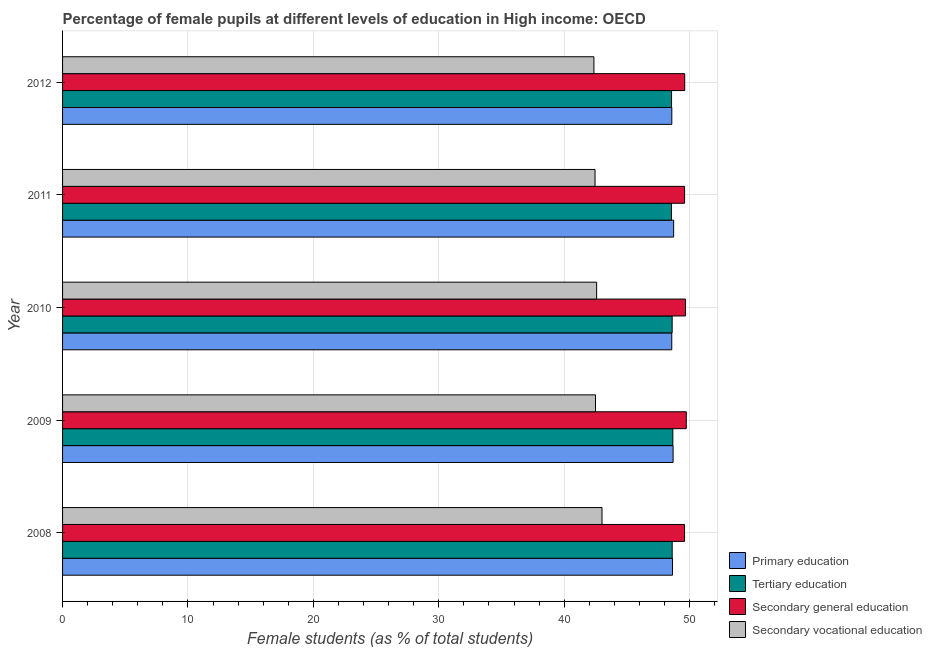How many groups of bars are there?
Your answer should be compact. 5. Are the number of bars per tick equal to the number of legend labels?
Provide a succinct answer. Yes. Are the number of bars on each tick of the Y-axis equal?
Ensure brevity in your answer.  Yes. How many bars are there on the 5th tick from the top?
Offer a very short reply. 4. How many bars are there on the 1st tick from the bottom?
Offer a terse response. 4. In how many cases, is the number of bars for a given year not equal to the number of legend labels?
Make the answer very short. 0. What is the percentage of female students in secondary vocational education in 2011?
Provide a succinct answer. 42.46. Across all years, what is the maximum percentage of female students in secondary vocational education?
Your answer should be compact. 43.01. Across all years, what is the minimum percentage of female students in secondary education?
Provide a short and direct response. 49.59. What is the total percentage of female students in primary education in the graph?
Your answer should be compact. 243.19. What is the difference between the percentage of female students in secondary education in 2008 and that in 2010?
Provide a short and direct response. -0.07. What is the difference between the percentage of female students in secondary vocational education in 2009 and the percentage of female students in tertiary education in 2012?
Ensure brevity in your answer.  -6.07. What is the average percentage of female students in tertiary education per year?
Your answer should be compact. 48.6. In the year 2010, what is the difference between the percentage of female students in secondary education and percentage of female students in secondary vocational education?
Offer a very short reply. 7.08. In how many years, is the percentage of female students in primary education greater than 48 %?
Your response must be concise. 5. Is the percentage of female students in secondary education in 2011 less than that in 2012?
Offer a very short reply. Yes. What is the difference between the highest and the second highest percentage of female students in secondary education?
Keep it short and to the point. 0.07. What is the difference between the highest and the lowest percentage of female students in primary education?
Your response must be concise. 0.15. In how many years, is the percentage of female students in primary education greater than the average percentage of female students in primary education taken over all years?
Offer a terse response. 2. Is the sum of the percentage of female students in tertiary education in 2008 and 2012 greater than the maximum percentage of female students in secondary education across all years?
Your response must be concise. Yes. What does the 2nd bar from the top in 2008 represents?
Ensure brevity in your answer.  Secondary general education. What does the 3rd bar from the bottom in 2008 represents?
Provide a succinct answer. Secondary general education. What is the difference between two consecutive major ticks on the X-axis?
Make the answer very short. 10. What is the title of the graph?
Provide a succinct answer. Percentage of female pupils at different levels of education in High income: OECD. What is the label or title of the X-axis?
Your answer should be very brief. Female students (as % of total students). What is the label or title of the Y-axis?
Offer a terse response. Year. What is the Female students (as % of total students) in Primary education in 2008?
Offer a terse response. 48.63. What is the Female students (as % of total students) in Tertiary education in 2008?
Provide a succinct answer. 48.61. What is the Female students (as % of total students) of Secondary general education in 2008?
Provide a succinct answer. 49.59. What is the Female students (as % of total students) in Secondary vocational education in 2008?
Offer a very short reply. 43.01. What is the Female students (as % of total students) in Primary education in 2009?
Offer a terse response. 48.68. What is the Female students (as % of total students) of Tertiary education in 2009?
Make the answer very short. 48.66. What is the Female students (as % of total students) of Secondary general education in 2009?
Offer a terse response. 49.73. What is the Female students (as % of total students) of Secondary vocational education in 2009?
Ensure brevity in your answer.  42.49. What is the Female students (as % of total students) in Primary education in 2010?
Your answer should be very brief. 48.57. What is the Female students (as % of total students) of Tertiary education in 2010?
Your response must be concise. 48.61. What is the Female students (as % of total students) of Secondary general education in 2010?
Make the answer very short. 49.67. What is the Female students (as % of total students) in Secondary vocational education in 2010?
Ensure brevity in your answer.  42.59. What is the Female students (as % of total students) of Primary education in 2011?
Offer a very short reply. 48.73. What is the Female students (as % of total students) in Tertiary education in 2011?
Offer a terse response. 48.55. What is the Female students (as % of total students) in Secondary general education in 2011?
Offer a very short reply. 49.6. What is the Female students (as % of total students) of Secondary vocational education in 2011?
Keep it short and to the point. 42.46. What is the Female students (as % of total students) of Primary education in 2012?
Keep it short and to the point. 48.58. What is the Female students (as % of total students) of Tertiary education in 2012?
Your answer should be compact. 48.56. What is the Female students (as % of total students) in Secondary general education in 2012?
Provide a succinct answer. 49.61. What is the Female students (as % of total students) in Secondary vocational education in 2012?
Your answer should be compact. 42.37. Across all years, what is the maximum Female students (as % of total students) of Primary education?
Give a very brief answer. 48.73. Across all years, what is the maximum Female students (as % of total students) in Tertiary education?
Your response must be concise. 48.66. Across all years, what is the maximum Female students (as % of total students) of Secondary general education?
Your answer should be very brief. 49.73. Across all years, what is the maximum Female students (as % of total students) of Secondary vocational education?
Provide a succinct answer. 43.01. Across all years, what is the minimum Female students (as % of total students) of Primary education?
Offer a terse response. 48.57. Across all years, what is the minimum Female students (as % of total students) in Tertiary education?
Your answer should be very brief. 48.55. Across all years, what is the minimum Female students (as % of total students) of Secondary general education?
Give a very brief answer. 49.59. Across all years, what is the minimum Female students (as % of total students) of Secondary vocational education?
Offer a very short reply. 42.37. What is the total Female students (as % of total students) in Primary education in the graph?
Make the answer very short. 243.19. What is the total Female students (as % of total students) in Tertiary education in the graph?
Ensure brevity in your answer.  242.98. What is the total Female students (as % of total students) of Secondary general education in the graph?
Keep it short and to the point. 248.2. What is the total Female students (as % of total students) of Secondary vocational education in the graph?
Ensure brevity in your answer.  212.92. What is the difference between the Female students (as % of total students) of Primary education in 2008 and that in 2009?
Your answer should be very brief. -0.05. What is the difference between the Female students (as % of total students) of Tertiary education in 2008 and that in 2009?
Provide a short and direct response. -0.05. What is the difference between the Female students (as % of total students) of Secondary general education in 2008 and that in 2009?
Your response must be concise. -0.14. What is the difference between the Female students (as % of total students) of Secondary vocational education in 2008 and that in 2009?
Keep it short and to the point. 0.52. What is the difference between the Female students (as % of total students) of Primary education in 2008 and that in 2010?
Provide a succinct answer. 0.06. What is the difference between the Female students (as % of total students) in Tertiary education in 2008 and that in 2010?
Offer a terse response. 0. What is the difference between the Female students (as % of total students) of Secondary general education in 2008 and that in 2010?
Make the answer very short. -0.07. What is the difference between the Female students (as % of total students) of Secondary vocational education in 2008 and that in 2010?
Give a very brief answer. 0.43. What is the difference between the Female students (as % of total students) in Primary education in 2008 and that in 2011?
Offer a very short reply. -0.09. What is the difference between the Female students (as % of total students) of Tertiary education in 2008 and that in 2011?
Keep it short and to the point. 0.06. What is the difference between the Female students (as % of total students) of Secondary general education in 2008 and that in 2011?
Give a very brief answer. -0. What is the difference between the Female students (as % of total students) in Secondary vocational education in 2008 and that in 2011?
Your answer should be very brief. 0.56. What is the difference between the Female students (as % of total students) in Primary education in 2008 and that in 2012?
Keep it short and to the point. 0.06. What is the difference between the Female students (as % of total students) in Tertiary education in 2008 and that in 2012?
Offer a terse response. 0.05. What is the difference between the Female students (as % of total students) of Secondary general education in 2008 and that in 2012?
Provide a short and direct response. -0.01. What is the difference between the Female students (as % of total students) of Secondary vocational education in 2008 and that in 2012?
Make the answer very short. 0.64. What is the difference between the Female students (as % of total students) in Primary education in 2009 and that in 2010?
Provide a short and direct response. 0.11. What is the difference between the Female students (as % of total students) in Tertiary education in 2009 and that in 2010?
Provide a short and direct response. 0.06. What is the difference between the Female students (as % of total students) in Secondary general education in 2009 and that in 2010?
Your response must be concise. 0.07. What is the difference between the Female students (as % of total students) of Secondary vocational education in 2009 and that in 2010?
Offer a terse response. -0.09. What is the difference between the Female students (as % of total students) of Primary education in 2009 and that in 2011?
Your response must be concise. -0.05. What is the difference between the Female students (as % of total students) in Tertiary education in 2009 and that in 2011?
Provide a short and direct response. 0.11. What is the difference between the Female students (as % of total students) of Secondary general education in 2009 and that in 2011?
Offer a terse response. 0.14. What is the difference between the Female students (as % of total students) in Secondary vocational education in 2009 and that in 2011?
Your answer should be very brief. 0.04. What is the difference between the Female students (as % of total students) in Primary education in 2009 and that in 2012?
Give a very brief answer. 0.1. What is the difference between the Female students (as % of total students) of Tertiary education in 2009 and that in 2012?
Offer a terse response. 0.1. What is the difference between the Female students (as % of total students) of Secondary general education in 2009 and that in 2012?
Offer a very short reply. 0.13. What is the difference between the Female students (as % of total students) in Secondary vocational education in 2009 and that in 2012?
Offer a terse response. 0.12. What is the difference between the Female students (as % of total students) of Primary education in 2010 and that in 2011?
Ensure brevity in your answer.  -0.15. What is the difference between the Female students (as % of total students) of Tertiary education in 2010 and that in 2011?
Your response must be concise. 0.06. What is the difference between the Female students (as % of total students) in Secondary general education in 2010 and that in 2011?
Your answer should be very brief. 0.07. What is the difference between the Female students (as % of total students) of Secondary vocational education in 2010 and that in 2011?
Your answer should be compact. 0.13. What is the difference between the Female students (as % of total students) in Primary education in 2010 and that in 2012?
Keep it short and to the point. -0. What is the difference between the Female students (as % of total students) in Tertiary education in 2010 and that in 2012?
Make the answer very short. 0.05. What is the difference between the Female students (as % of total students) in Secondary vocational education in 2010 and that in 2012?
Ensure brevity in your answer.  0.22. What is the difference between the Female students (as % of total students) of Primary education in 2011 and that in 2012?
Provide a short and direct response. 0.15. What is the difference between the Female students (as % of total students) of Tertiary education in 2011 and that in 2012?
Your answer should be compact. -0.01. What is the difference between the Female students (as % of total students) in Secondary general education in 2011 and that in 2012?
Your answer should be very brief. -0.01. What is the difference between the Female students (as % of total students) in Secondary vocational education in 2011 and that in 2012?
Ensure brevity in your answer.  0.09. What is the difference between the Female students (as % of total students) of Primary education in 2008 and the Female students (as % of total students) of Tertiary education in 2009?
Give a very brief answer. -0.03. What is the difference between the Female students (as % of total students) of Primary education in 2008 and the Female students (as % of total students) of Secondary general education in 2009?
Make the answer very short. -1.1. What is the difference between the Female students (as % of total students) in Primary education in 2008 and the Female students (as % of total students) in Secondary vocational education in 2009?
Offer a terse response. 6.14. What is the difference between the Female students (as % of total students) of Tertiary education in 2008 and the Female students (as % of total students) of Secondary general education in 2009?
Offer a very short reply. -1.12. What is the difference between the Female students (as % of total students) of Tertiary education in 2008 and the Female students (as % of total students) of Secondary vocational education in 2009?
Provide a succinct answer. 6.12. What is the difference between the Female students (as % of total students) of Secondary general education in 2008 and the Female students (as % of total students) of Secondary vocational education in 2009?
Provide a succinct answer. 7.1. What is the difference between the Female students (as % of total students) in Primary education in 2008 and the Female students (as % of total students) in Tertiary education in 2010?
Keep it short and to the point. 0.03. What is the difference between the Female students (as % of total students) in Primary education in 2008 and the Female students (as % of total students) in Secondary general education in 2010?
Make the answer very short. -1.03. What is the difference between the Female students (as % of total students) in Primary education in 2008 and the Female students (as % of total students) in Secondary vocational education in 2010?
Keep it short and to the point. 6.05. What is the difference between the Female students (as % of total students) of Tertiary education in 2008 and the Female students (as % of total students) of Secondary general education in 2010?
Your answer should be very brief. -1.06. What is the difference between the Female students (as % of total students) of Tertiary education in 2008 and the Female students (as % of total students) of Secondary vocational education in 2010?
Offer a terse response. 6.02. What is the difference between the Female students (as % of total students) of Secondary general education in 2008 and the Female students (as % of total students) of Secondary vocational education in 2010?
Ensure brevity in your answer.  7.01. What is the difference between the Female students (as % of total students) in Primary education in 2008 and the Female students (as % of total students) in Tertiary education in 2011?
Your answer should be compact. 0.09. What is the difference between the Female students (as % of total students) in Primary education in 2008 and the Female students (as % of total students) in Secondary general education in 2011?
Provide a short and direct response. -0.96. What is the difference between the Female students (as % of total students) of Primary education in 2008 and the Female students (as % of total students) of Secondary vocational education in 2011?
Your answer should be compact. 6.18. What is the difference between the Female students (as % of total students) in Tertiary education in 2008 and the Female students (as % of total students) in Secondary general education in 2011?
Provide a short and direct response. -0.99. What is the difference between the Female students (as % of total students) of Tertiary education in 2008 and the Female students (as % of total students) of Secondary vocational education in 2011?
Offer a terse response. 6.15. What is the difference between the Female students (as % of total students) in Secondary general education in 2008 and the Female students (as % of total students) in Secondary vocational education in 2011?
Offer a very short reply. 7.14. What is the difference between the Female students (as % of total students) in Primary education in 2008 and the Female students (as % of total students) in Tertiary education in 2012?
Provide a short and direct response. 0.08. What is the difference between the Female students (as % of total students) in Primary education in 2008 and the Female students (as % of total students) in Secondary general education in 2012?
Your answer should be compact. -0.97. What is the difference between the Female students (as % of total students) of Primary education in 2008 and the Female students (as % of total students) of Secondary vocational education in 2012?
Give a very brief answer. 6.27. What is the difference between the Female students (as % of total students) of Tertiary education in 2008 and the Female students (as % of total students) of Secondary general education in 2012?
Offer a very short reply. -1. What is the difference between the Female students (as % of total students) of Tertiary education in 2008 and the Female students (as % of total students) of Secondary vocational education in 2012?
Give a very brief answer. 6.24. What is the difference between the Female students (as % of total students) in Secondary general education in 2008 and the Female students (as % of total students) in Secondary vocational education in 2012?
Give a very brief answer. 7.23. What is the difference between the Female students (as % of total students) in Primary education in 2009 and the Female students (as % of total students) in Tertiary education in 2010?
Provide a short and direct response. 0.07. What is the difference between the Female students (as % of total students) in Primary education in 2009 and the Female students (as % of total students) in Secondary general education in 2010?
Give a very brief answer. -0.99. What is the difference between the Female students (as % of total students) of Primary education in 2009 and the Female students (as % of total students) of Secondary vocational education in 2010?
Your response must be concise. 6.1. What is the difference between the Female students (as % of total students) in Tertiary education in 2009 and the Female students (as % of total students) in Secondary general education in 2010?
Offer a terse response. -1.01. What is the difference between the Female students (as % of total students) of Tertiary education in 2009 and the Female students (as % of total students) of Secondary vocational education in 2010?
Provide a succinct answer. 6.08. What is the difference between the Female students (as % of total students) of Secondary general education in 2009 and the Female students (as % of total students) of Secondary vocational education in 2010?
Keep it short and to the point. 7.15. What is the difference between the Female students (as % of total students) in Primary education in 2009 and the Female students (as % of total students) in Tertiary education in 2011?
Give a very brief answer. 0.13. What is the difference between the Female students (as % of total students) of Primary education in 2009 and the Female students (as % of total students) of Secondary general education in 2011?
Your answer should be compact. -0.92. What is the difference between the Female students (as % of total students) in Primary education in 2009 and the Female students (as % of total students) in Secondary vocational education in 2011?
Make the answer very short. 6.22. What is the difference between the Female students (as % of total students) in Tertiary education in 2009 and the Female students (as % of total students) in Secondary general education in 2011?
Keep it short and to the point. -0.94. What is the difference between the Female students (as % of total students) of Tertiary education in 2009 and the Female students (as % of total students) of Secondary vocational education in 2011?
Your response must be concise. 6.2. What is the difference between the Female students (as % of total students) of Secondary general education in 2009 and the Female students (as % of total students) of Secondary vocational education in 2011?
Provide a succinct answer. 7.28. What is the difference between the Female students (as % of total students) in Primary education in 2009 and the Female students (as % of total students) in Tertiary education in 2012?
Ensure brevity in your answer.  0.12. What is the difference between the Female students (as % of total students) of Primary education in 2009 and the Female students (as % of total students) of Secondary general education in 2012?
Offer a terse response. -0.93. What is the difference between the Female students (as % of total students) of Primary education in 2009 and the Female students (as % of total students) of Secondary vocational education in 2012?
Your answer should be compact. 6.31. What is the difference between the Female students (as % of total students) in Tertiary education in 2009 and the Female students (as % of total students) in Secondary general education in 2012?
Offer a terse response. -0.95. What is the difference between the Female students (as % of total students) in Tertiary education in 2009 and the Female students (as % of total students) in Secondary vocational education in 2012?
Provide a succinct answer. 6.29. What is the difference between the Female students (as % of total students) of Secondary general education in 2009 and the Female students (as % of total students) of Secondary vocational education in 2012?
Make the answer very short. 7.36. What is the difference between the Female students (as % of total students) of Primary education in 2010 and the Female students (as % of total students) of Tertiary education in 2011?
Your answer should be very brief. 0.03. What is the difference between the Female students (as % of total students) of Primary education in 2010 and the Female students (as % of total students) of Secondary general education in 2011?
Make the answer very short. -1.02. What is the difference between the Female students (as % of total students) of Primary education in 2010 and the Female students (as % of total students) of Secondary vocational education in 2011?
Provide a succinct answer. 6.12. What is the difference between the Female students (as % of total students) of Tertiary education in 2010 and the Female students (as % of total students) of Secondary general education in 2011?
Provide a short and direct response. -0.99. What is the difference between the Female students (as % of total students) of Tertiary education in 2010 and the Female students (as % of total students) of Secondary vocational education in 2011?
Ensure brevity in your answer.  6.15. What is the difference between the Female students (as % of total students) in Secondary general education in 2010 and the Female students (as % of total students) in Secondary vocational education in 2011?
Provide a succinct answer. 7.21. What is the difference between the Female students (as % of total students) in Primary education in 2010 and the Female students (as % of total students) in Tertiary education in 2012?
Your answer should be very brief. 0.02. What is the difference between the Female students (as % of total students) of Primary education in 2010 and the Female students (as % of total students) of Secondary general education in 2012?
Provide a succinct answer. -1.03. What is the difference between the Female students (as % of total students) of Primary education in 2010 and the Female students (as % of total students) of Secondary vocational education in 2012?
Offer a very short reply. 6.21. What is the difference between the Female students (as % of total students) in Tertiary education in 2010 and the Female students (as % of total students) in Secondary general education in 2012?
Give a very brief answer. -1. What is the difference between the Female students (as % of total students) in Tertiary education in 2010 and the Female students (as % of total students) in Secondary vocational education in 2012?
Keep it short and to the point. 6.24. What is the difference between the Female students (as % of total students) in Secondary general education in 2010 and the Female students (as % of total students) in Secondary vocational education in 2012?
Provide a short and direct response. 7.3. What is the difference between the Female students (as % of total students) in Primary education in 2011 and the Female students (as % of total students) in Tertiary education in 2012?
Ensure brevity in your answer.  0.17. What is the difference between the Female students (as % of total students) of Primary education in 2011 and the Female students (as % of total students) of Secondary general education in 2012?
Offer a terse response. -0.88. What is the difference between the Female students (as % of total students) in Primary education in 2011 and the Female students (as % of total students) in Secondary vocational education in 2012?
Your answer should be compact. 6.36. What is the difference between the Female students (as % of total students) in Tertiary education in 2011 and the Female students (as % of total students) in Secondary general education in 2012?
Offer a terse response. -1.06. What is the difference between the Female students (as % of total students) in Tertiary education in 2011 and the Female students (as % of total students) in Secondary vocational education in 2012?
Give a very brief answer. 6.18. What is the difference between the Female students (as % of total students) of Secondary general education in 2011 and the Female students (as % of total students) of Secondary vocational education in 2012?
Your response must be concise. 7.23. What is the average Female students (as % of total students) of Primary education per year?
Provide a short and direct response. 48.64. What is the average Female students (as % of total students) in Tertiary education per year?
Provide a short and direct response. 48.6. What is the average Female students (as % of total students) of Secondary general education per year?
Give a very brief answer. 49.64. What is the average Female students (as % of total students) in Secondary vocational education per year?
Ensure brevity in your answer.  42.58. In the year 2008, what is the difference between the Female students (as % of total students) of Primary education and Female students (as % of total students) of Tertiary education?
Your response must be concise. 0.03. In the year 2008, what is the difference between the Female students (as % of total students) in Primary education and Female students (as % of total students) in Secondary general education?
Your answer should be compact. -0.96. In the year 2008, what is the difference between the Female students (as % of total students) in Primary education and Female students (as % of total students) in Secondary vocational education?
Offer a terse response. 5.62. In the year 2008, what is the difference between the Female students (as % of total students) in Tertiary education and Female students (as % of total students) in Secondary general education?
Keep it short and to the point. -0.99. In the year 2008, what is the difference between the Female students (as % of total students) of Tertiary education and Female students (as % of total students) of Secondary vocational education?
Ensure brevity in your answer.  5.6. In the year 2008, what is the difference between the Female students (as % of total students) in Secondary general education and Female students (as % of total students) in Secondary vocational education?
Offer a terse response. 6.58. In the year 2009, what is the difference between the Female students (as % of total students) in Primary education and Female students (as % of total students) in Tertiary education?
Offer a very short reply. 0.02. In the year 2009, what is the difference between the Female students (as % of total students) of Primary education and Female students (as % of total students) of Secondary general education?
Offer a terse response. -1.05. In the year 2009, what is the difference between the Female students (as % of total students) of Primary education and Female students (as % of total students) of Secondary vocational education?
Your response must be concise. 6.19. In the year 2009, what is the difference between the Female students (as % of total students) of Tertiary education and Female students (as % of total students) of Secondary general education?
Make the answer very short. -1.07. In the year 2009, what is the difference between the Female students (as % of total students) in Tertiary education and Female students (as % of total students) in Secondary vocational education?
Provide a succinct answer. 6.17. In the year 2009, what is the difference between the Female students (as % of total students) in Secondary general education and Female students (as % of total students) in Secondary vocational education?
Your response must be concise. 7.24. In the year 2010, what is the difference between the Female students (as % of total students) in Primary education and Female students (as % of total students) in Tertiary education?
Your answer should be compact. -0.03. In the year 2010, what is the difference between the Female students (as % of total students) in Primary education and Female students (as % of total students) in Secondary general education?
Provide a short and direct response. -1.09. In the year 2010, what is the difference between the Female students (as % of total students) in Primary education and Female students (as % of total students) in Secondary vocational education?
Offer a terse response. 5.99. In the year 2010, what is the difference between the Female students (as % of total students) of Tertiary education and Female students (as % of total students) of Secondary general education?
Your answer should be very brief. -1.06. In the year 2010, what is the difference between the Female students (as % of total students) of Tertiary education and Female students (as % of total students) of Secondary vocational education?
Ensure brevity in your answer.  6.02. In the year 2010, what is the difference between the Female students (as % of total students) of Secondary general education and Female students (as % of total students) of Secondary vocational education?
Give a very brief answer. 7.08. In the year 2011, what is the difference between the Female students (as % of total students) in Primary education and Female students (as % of total students) in Tertiary education?
Offer a very short reply. 0.18. In the year 2011, what is the difference between the Female students (as % of total students) of Primary education and Female students (as % of total students) of Secondary general education?
Your answer should be compact. -0.87. In the year 2011, what is the difference between the Female students (as % of total students) in Primary education and Female students (as % of total students) in Secondary vocational education?
Your answer should be compact. 6.27. In the year 2011, what is the difference between the Female students (as % of total students) in Tertiary education and Female students (as % of total students) in Secondary general education?
Keep it short and to the point. -1.05. In the year 2011, what is the difference between the Female students (as % of total students) in Tertiary education and Female students (as % of total students) in Secondary vocational education?
Make the answer very short. 6.09. In the year 2011, what is the difference between the Female students (as % of total students) of Secondary general education and Female students (as % of total students) of Secondary vocational education?
Make the answer very short. 7.14. In the year 2012, what is the difference between the Female students (as % of total students) in Primary education and Female students (as % of total students) in Tertiary education?
Offer a very short reply. 0.02. In the year 2012, what is the difference between the Female students (as % of total students) of Primary education and Female students (as % of total students) of Secondary general education?
Provide a short and direct response. -1.03. In the year 2012, what is the difference between the Female students (as % of total students) in Primary education and Female students (as % of total students) in Secondary vocational education?
Your response must be concise. 6.21. In the year 2012, what is the difference between the Female students (as % of total students) in Tertiary education and Female students (as % of total students) in Secondary general education?
Your answer should be very brief. -1.05. In the year 2012, what is the difference between the Female students (as % of total students) of Tertiary education and Female students (as % of total students) of Secondary vocational education?
Ensure brevity in your answer.  6.19. In the year 2012, what is the difference between the Female students (as % of total students) of Secondary general education and Female students (as % of total students) of Secondary vocational education?
Your answer should be very brief. 7.24. What is the ratio of the Female students (as % of total students) of Primary education in 2008 to that in 2009?
Offer a very short reply. 1. What is the ratio of the Female students (as % of total students) of Tertiary education in 2008 to that in 2009?
Your answer should be compact. 1. What is the ratio of the Female students (as % of total students) of Secondary general education in 2008 to that in 2009?
Ensure brevity in your answer.  1. What is the ratio of the Female students (as % of total students) in Secondary vocational education in 2008 to that in 2009?
Make the answer very short. 1.01. What is the ratio of the Female students (as % of total students) in Tertiary education in 2008 to that in 2010?
Your answer should be compact. 1. What is the ratio of the Female students (as % of total students) in Secondary general education in 2008 to that in 2010?
Your answer should be very brief. 1. What is the ratio of the Female students (as % of total students) in Secondary vocational education in 2008 to that in 2010?
Offer a very short reply. 1.01. What is the ratio of the Female students (as % of total students) of Primary education in 2008 to that in 2011?
Provide a short and direct response. 1. What is the ratio of the Female students (as % of total students) of Tertiary education in 2008 to that in 2011?
Offer a terse response. 1. What is the ratio of the Female students (as % of total students) in Secondary general education in 2008 to that in 2011?
Offer a terse response. 1. What is the ratio of the Female students (as % of total students) of Secondary vocational education in 2008 to that in 2011?
Your response must be concise. 1.01. What is the ratio of the Female students (as % of total students) in Tertiary education in 2008 to that in 2012?
Your answer should be very brief. 1. What is the ratio of the Female students (as % of total students) in Secondary vocational education in 2008 to that in 2012?
Keep it short and to the point. 1.02. What is the ratio of the Female students (as % of total students) of Tertiary education in 2009 to that in 2010?
Offer a terse response. 1. What is the ratio of the Female students (as % of total students) in Secondary general education in 2009 to that in 2010?
Your answer should be very brief. 1. What is the ratio of the Female students (as % of total students) in Secondary general education in 2009 to that in 2011?
Offer a very short reply. 1. What is the ratio of the Female students (as % of total students) of Secondary vocational education in 2009 to that in 2011?
Give a very brief answer. 1. What is the ratio of the Female students (as % of total students) of Tertiary education in 2009 to that in 2012?
Your response must be concise. 1. What is the ratio of the Female students (as % of total students) in Primary education in 2010 to that in 2011?
Your response must be concise. 1. What is the ratio of the Female students (as % of total students) in Secondary vocational education in 2010 to that in 2011?
Make the answer very short. 1. What is the ratio of the Female students (as % of total students) of Primary education in 2010 to that in 2012?
Provide a short and direct response. 1. What is the ratio of the Female students (as % of total students) in Secondary vocational education in 2010 to that in 2012?
Your response must be concise. 1.01. What is the ratio of the Female students (as % of total students) of Secondary general education in 2011 to that in 2012?
Give a very brief answer. 1. What is the difference between the highest and the second highest Female students (as % of total students) in Primary education?
Offer a terse response. 0.05. What is the difference between the highest and the second highest Female students (as % of total students) of Tertiary education?
Offer a very short reply. 0.05. What is the difference between the highest and the second highest Female students (as % of total students) in Secondary general education?
Provide a short and direct response. 0.07. What is the difference between the highest and the second highest Female students (as % of total students) in Secondary vocational education?
Offer a very short reply. 0.43. What is the difference between the highest and the lowest Female students (as % of total students) of Primary education?
Your answer should be very brief. 0.15. What is the difference between the highest and the lowest Female students (as % of total students) of Tertiary education?
Keep it short and to the point. 0.11. What is the difference between the highest and the lowest Female students (as % of total students) in Secondary general education?
Your answer should be very brief. 0.14. What is the difference between the highest and the lowest Female students (as % of total students) of Secondary vocational education?
Your response must be concise. 0.64. 